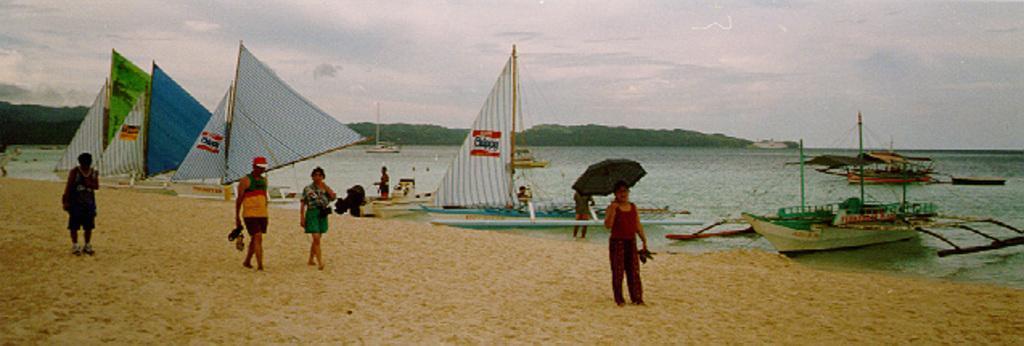Describe this image in one or two sentences. In this image I can see few people and few are holding umbrella and something. Back I can see few boats,water,mountains. The sky is in white and blue color. 